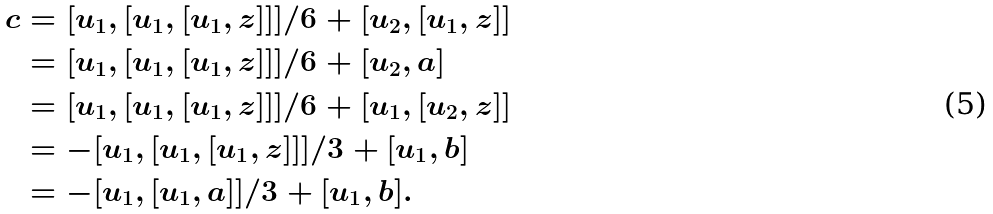Convert formula to latex. <formula><loc_0><loc_0><loc_500><loc_500>c & = [ u _ { 1 } , [ u _ { 1 } , [ u _ { 1 } , z ] ] ] / 6 + [ u _ { 2 } , [ u _ { 1 } , z ] ] \\ & = [ u _ { 1 } , [ u _ { 1 } , [ u _ { 1 } , z ] ] ] / 6 + [ u _ { 2 } , a ] \\ & = [ u _ { 1 } , [ u _ { 1 } , [ u _ { 1 } , z ] ] ] / 6 + [ u _ { 1 } , [ u _ { 2 } , z ] ] \\ & = - [ u _ { 1 } , [ u _ { 1 } , [ u _ { 1 } , z ] ] ] / 3 + [ u _ { 1 } , b ] \\ & = - [ u _ { 1 } , [ u _ { 1 } , a ] ] / 3 + [ u _ { 1 } , b ] .</formula> 